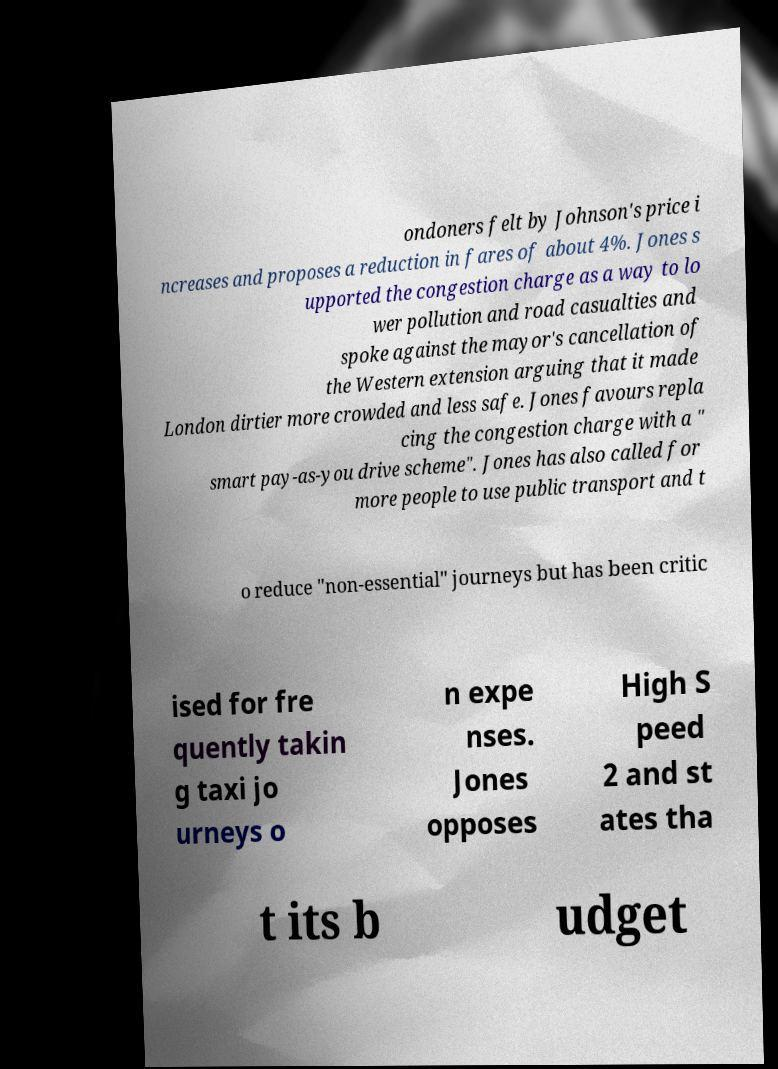Can you read and provide the text displayed in the image?This photo seems to have some interesting text. Can you extract and type it out for me? ondoners felt by Johnson's price i ncreases and proposes a reduction in fares of about 4%. Jones s upported the congestion charge as a way to lo wer pollution and road casualties and spoke against the mayor's cancellation of the Western extension arguing that it made London dirtier more crowded and less safe. Jones favours repla cing the congestion charge with a " smart pay-as-you drive scheme". Jones has also called for more people to use public transport and t o reduce "non-essential" journeys but has been critic ised for fre quently takin g taxi jo urneys o n expe nses. Jones opposes High S peed 2 and st ates tha t its b udget 